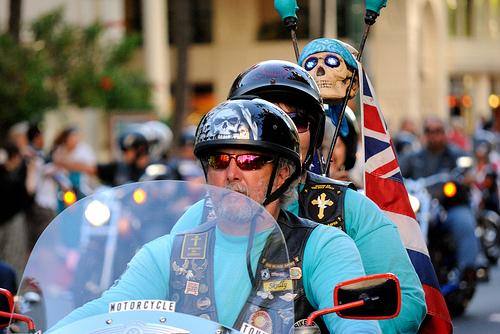How many mirrors are there on the motorcycle, and can you describe their color and positioning? There are two side mirrors on the motorcycle, both black and framed in red, positioned on the left and right sides of the bike. Describe the details of the skull visible in the image. The skull appears to be wearing a blue bandana and is likely a decoration on the back of the bike. Provide details on the flag's placement and its size in relation to the image. The flag is located at the back of the motorcycle and has a width of 100 and height of 100, making it a relatively large object in the scene. Examine and analyze the available information on the sunglasses worn by the man. The man is wearing sunglasses, and there seems to be a reflection in the lenses, possibly of the surroundings or other objects. Can you tell me what kind of headwear the man has on and its color? The man is wearing a black helmet, possibly with a skull design. Assess the overall quality of the image based on the given information and provide any suggestions for improvement. The overall quality of the image is quite detailed, with accurate object detection and placement. However, some objects may be better represented with more precise coordinates and sizes for further analysis. What can you say about the state of people present in the background of the image? There are people in the background, but they appear to be blurred and less detailed, possibly riding bikes or standing around. Identify the object that shields the riders from the wind and describe its position. The object is a windshield on the motorcycle, located at the front part to protect the riders from the wind. Analyze the sentiments conveyed by the image and explain your reasoning. The image conveys a sense of adventure and freedom, as the man and woman are riding a motorcycle, wearing cool accessories, and displaying a skull decoration. What is the color of the man's shirt and what is their main activity? The man is wearing a blue shirt and he is riding a motorcycle with a woman. 